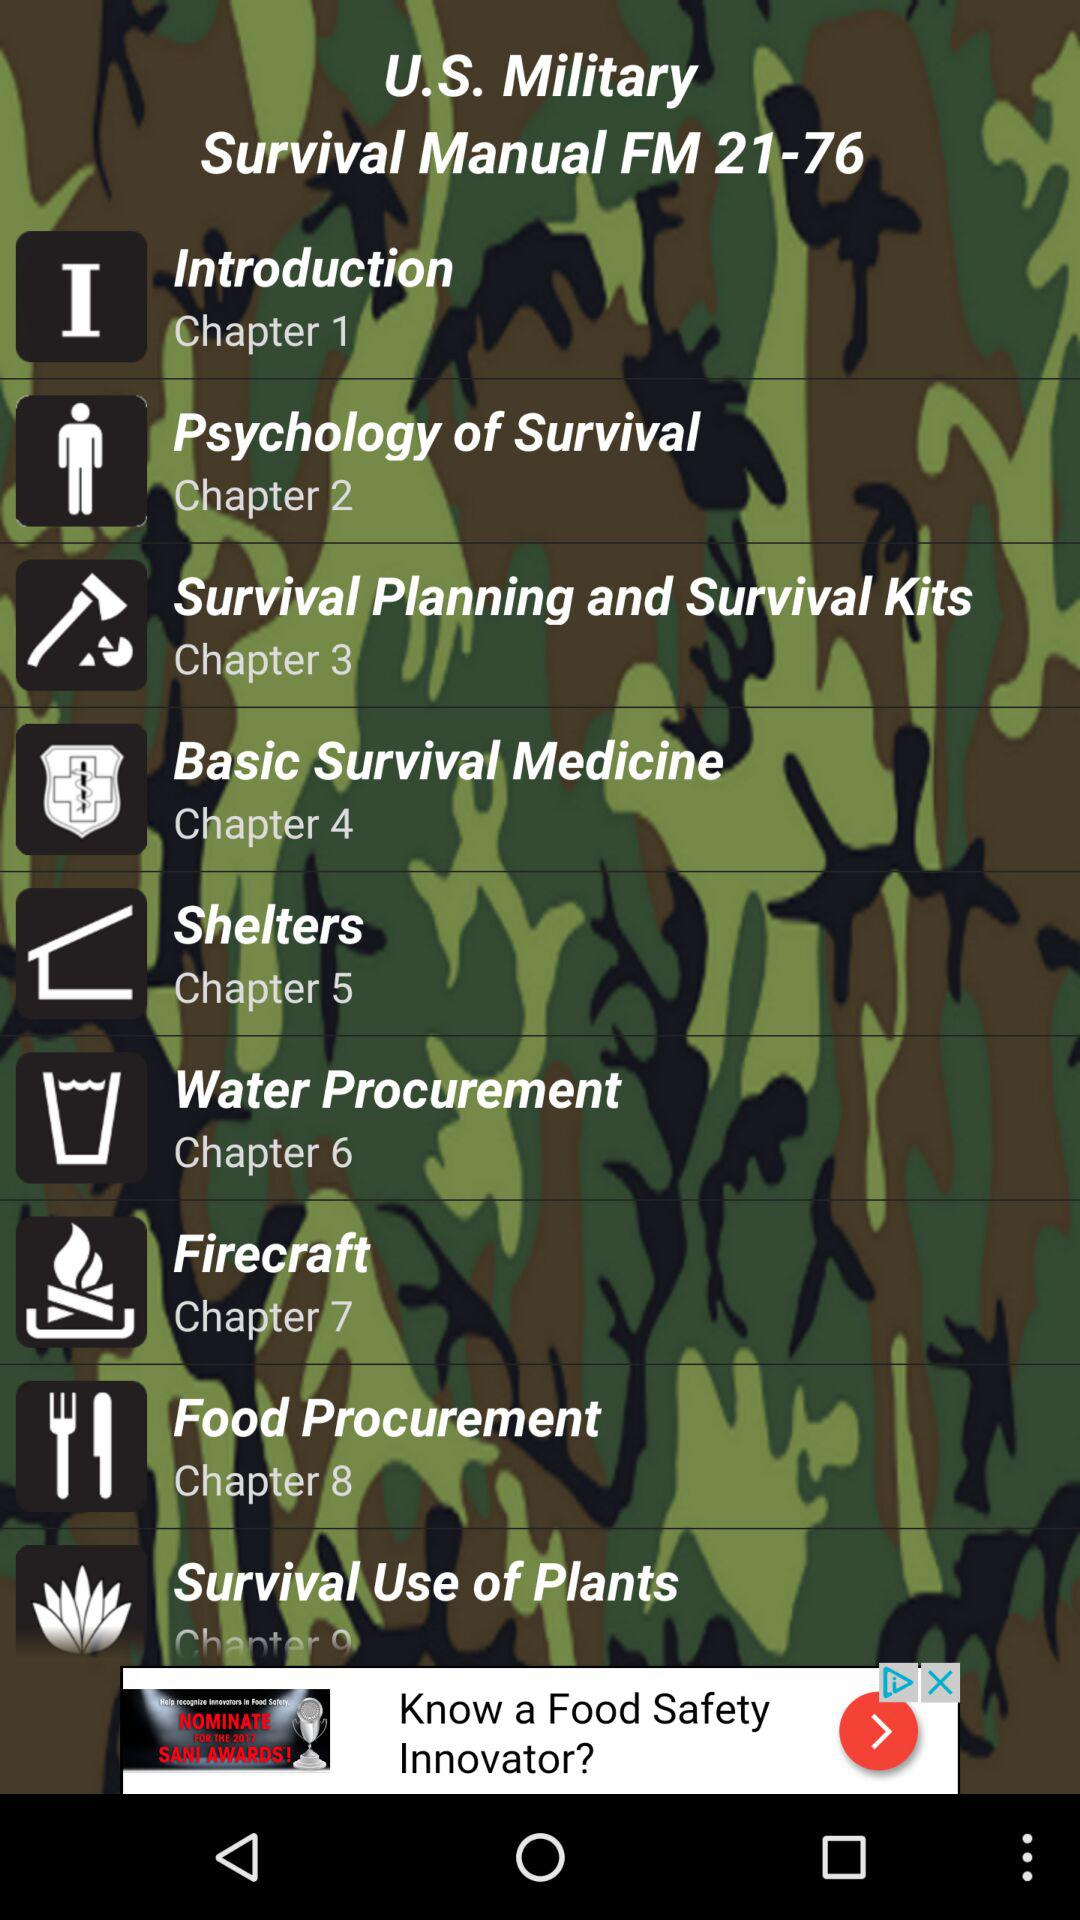What is the name of Chapter 5? The name of the chapter is "Shelters". 